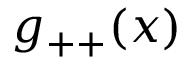<formula> <loc_0><loc_0><loc_500><loc_500>g _ { + + } ( x )</formula> 